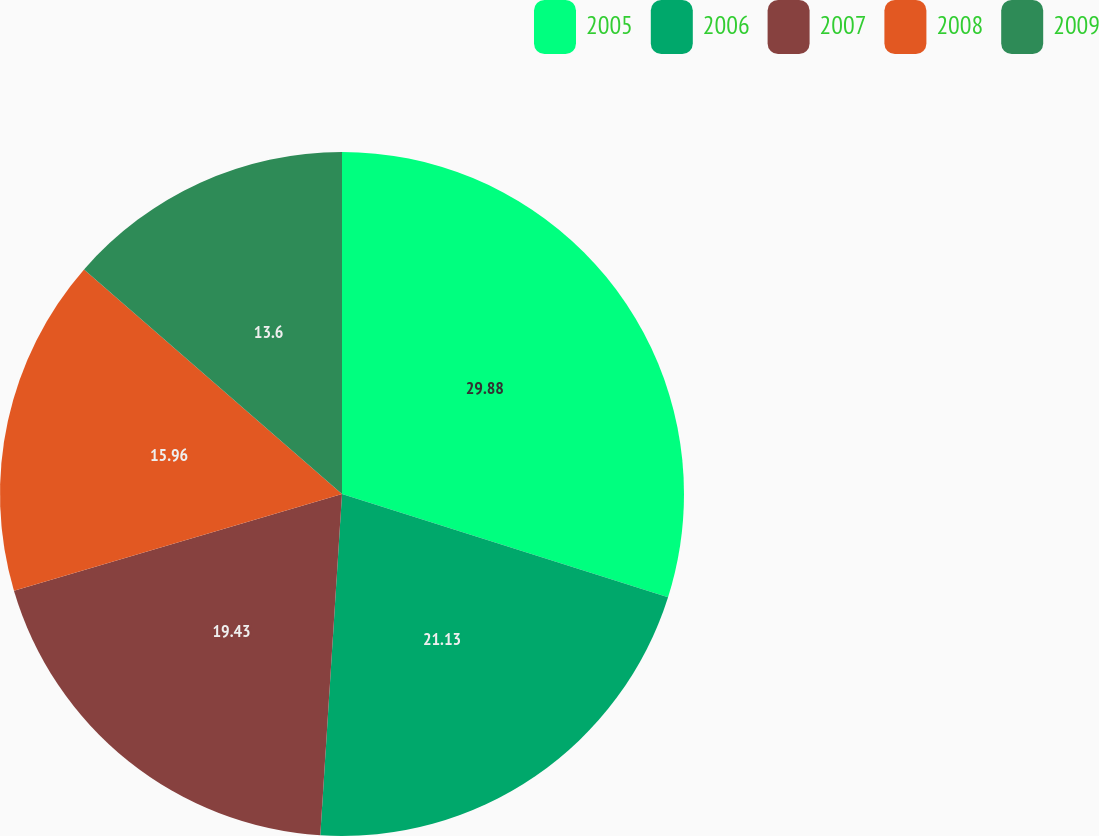Convert chart to OTSL. <chart><loc_0><loc_0><loc_500><loc_500><pie_chart><fcel>2005<fcel>2006<fcel>2007<fcel>2008<fcel>2009<nl><fcel>29.88%<fcel>21.13%<fcel>19.43%<fcel>15.96%<fcel>13.6%<nl></chart> 